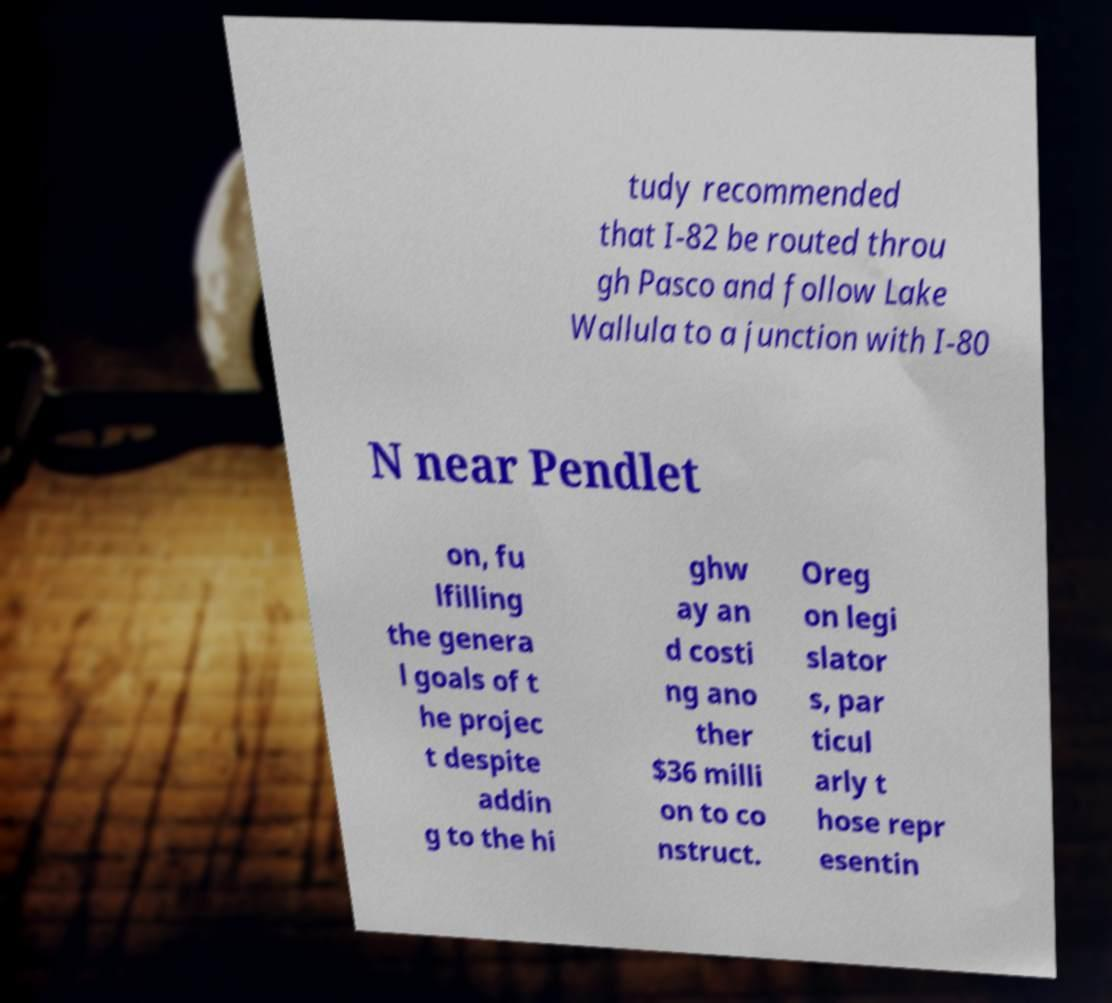Could you assist in decoding the text presented in this image and type it out clearly? tudy recommended that I-82 be routed throu gh Pasco and follow Lake Wallula to a junction with I-80 N near Pendlet on, fu lfilling the genera l goals of t he projec t despite addin g to the hi ghw ay an d costi ng ano ther $36 milli on to co nstruct. Oreg on legi slator s, par ticul arly t hose repr esentin 